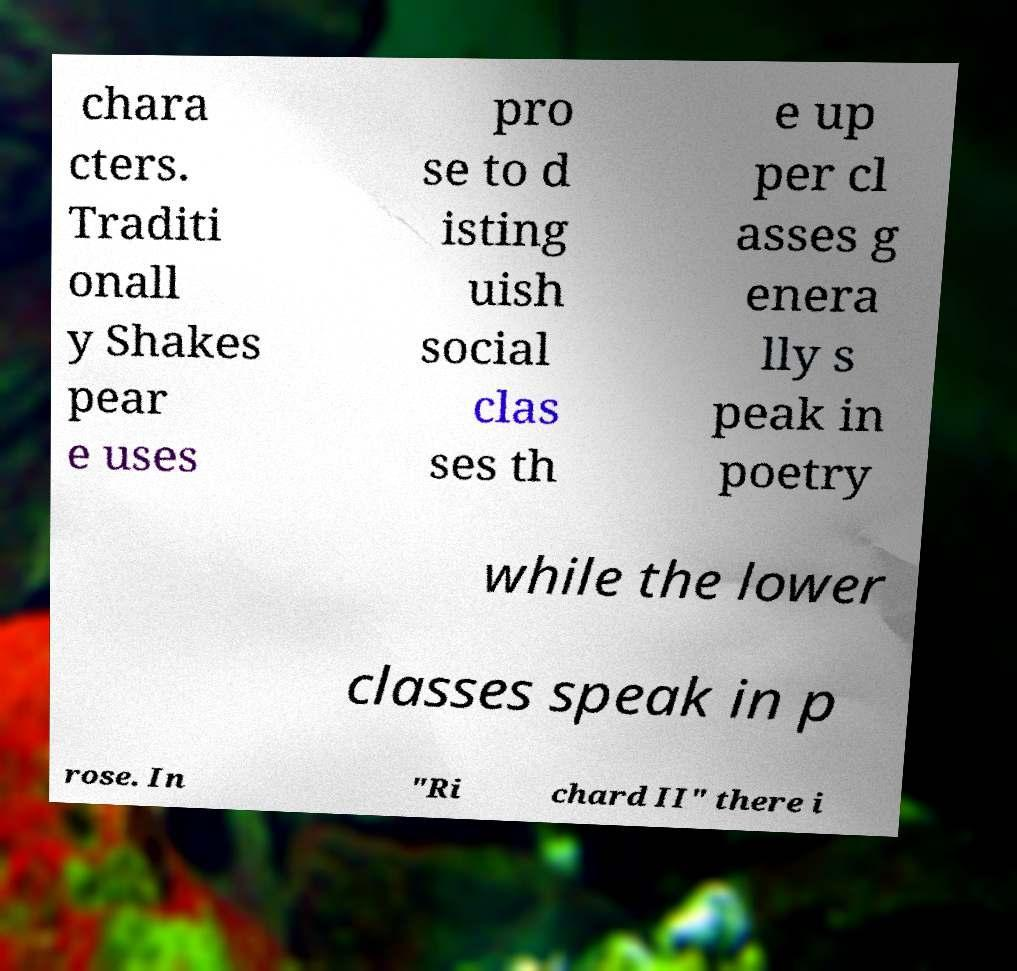Could you extract and type out the text from this image? chara cters. Traditi onall y Shakes pear e uses pro se to d isting uish social clas ses th e up per cl asses g enera lly s peak in poetry while the lower classes speak in p rose. In "Ri chard II" there i 